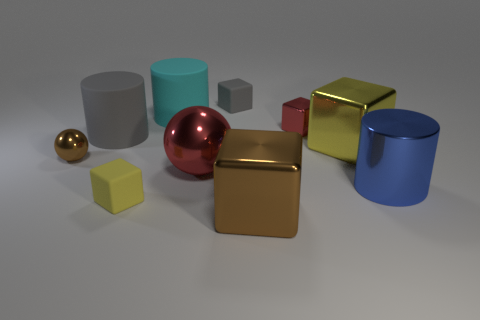Are there any repeating patterns or symmetry in this composition? There are no immediate repeating patterns or explicit symmetry in this composition. Each object is unique in size and color, and they are arranged without any obvious pattern or symmetrical order, giving a sense of random placement on the surface. 